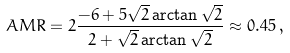Convert formula to latex. <formula><loc_0><loc_0><loc_500><loc_500>A M R = 2 \frac { - 6 + 5 \sqrt { 2 } \arctan \sqrt { 2 } } { 2 + \sqrt { 2 } \arctan \sqrt { 2 } } \approx 0 . 4 5 \, ,</formula> 